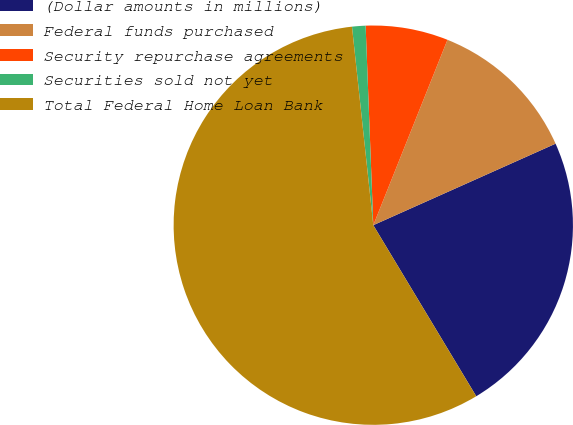Convert chart. <chart><loc_0><loc_0><loc_500><loc_500><pie_chart><fcel>(Dollar amounts in millions)<fcel>Federal funds purchased<fcel>Security repurchase agreements<fcel>Securities sold not yet<fcel>Total Federal Home Loan Bank<nl><fcel>23.07%<fcel>12.25%<fcel>6.67%<fcel>1.09%<fcel>56.92%<nl></chart> 